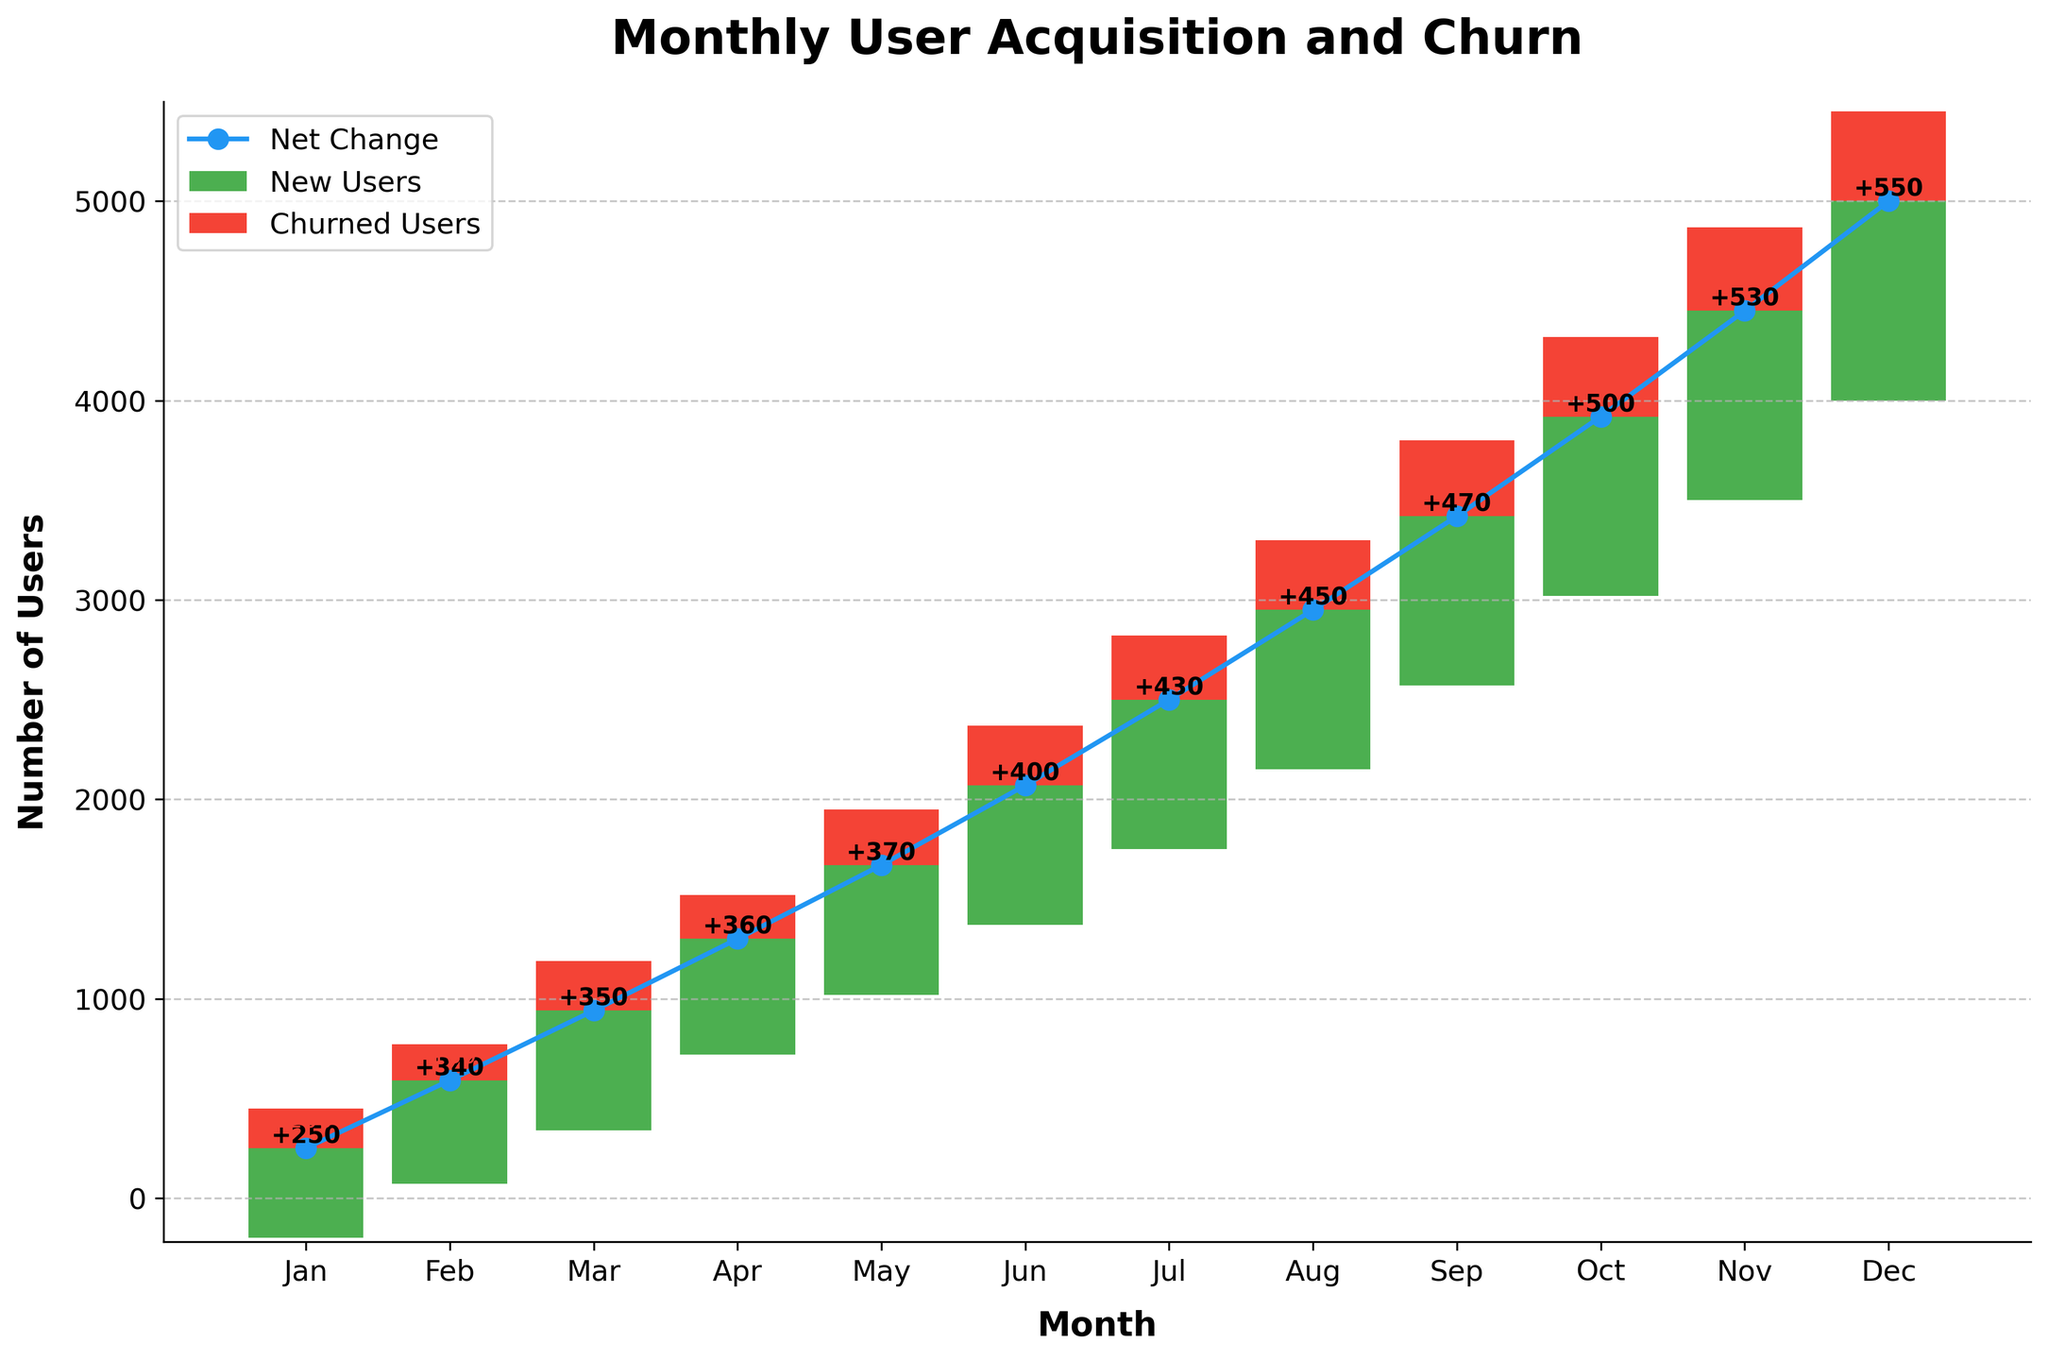What is the title of the chart? The title of the chart is located at the top and usually summarizes the chart's content. In this case, it's clearly written as "Monthly User Acquisition and Churn."
Answer: Monthly User Acquisition and Churn How many months are represented in the chart? Each bar in the chart represents a month. By counting these bars or the labels on the x-axis, we can see that there are 12 months from January to December.
Answer: 12 What color represents the new users in the chart? The color of the bars representing new users can be identified by looking at the chart. The new users are shown in green, as indicated by the legend.
Answer: Green What is the net change in users for June? For June, the net change is directly labeled on the associated line point within the chart. There, we can see the value for June is 400.
Answer: 400 How many new users joined in September? The number of new users for each month is given by the height of the green bars. For September, the green bar is labeled '+850', indicating 850 new users.
Answer: 850 What is the difference between new users and churned users in February? In February, the new users are 520, and churned users are -180. The difference can be calculated as 520 - 180.
Answer: 340 Which month had the highest churned users? By looking at each red bar which represents churned users and comparing their heights, we can see that December had the highest churned users at -450.
Answer: December What is the cumulative user change by the end of May? To find the cumulative change by May, we sum the net changes up to May: 250+340+350+360+370 = 1670.
Answer: 1670 Is there a month where the net change in users is equal to the number of new users? We can see that for each month, the net change is not equal to the number of new users as the net change includes the subtraction of churned users. By checking, this is evident in each month as none of the net changes are the same as the new user numbers.
Answer: No How does the net change in October compare to that in March? By comparing the line markers for October and March, we see October has a net change of 500 and March has 350. October has a higher net change.
Answer: October has a higher change 